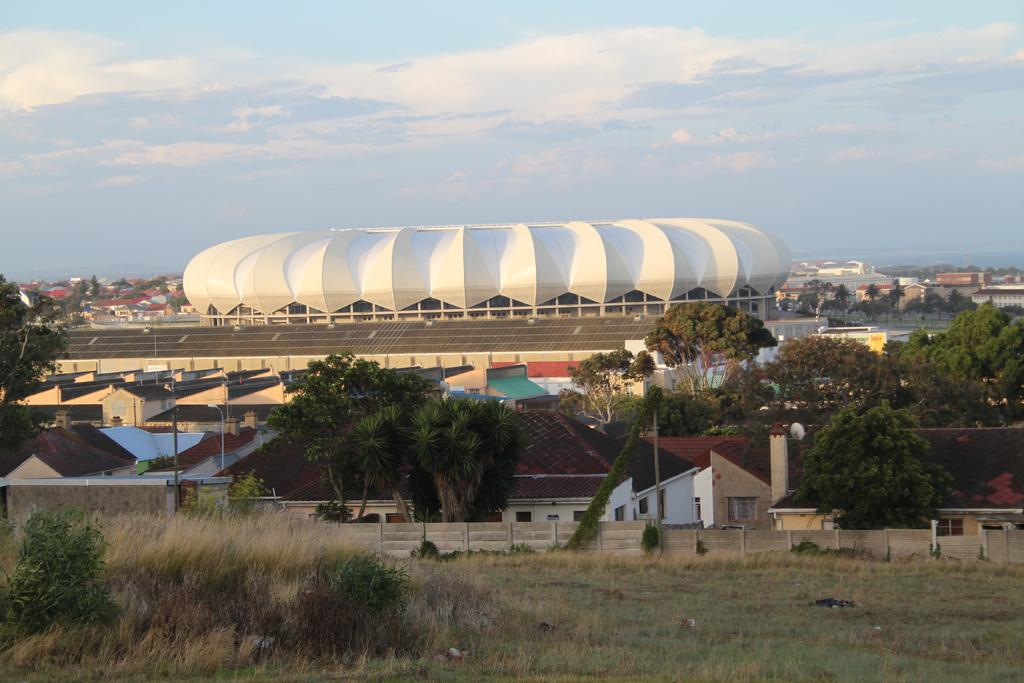What type of structures can be seen in the image? There are buildings in the image. What type of vegetation is present in the image? There are trees in the image. What type of ground surface is visible in the image? There is grass visible in the image. What type of vertical structures are present in the image? There are poles in the image. What part of the natural environment is visible in the image? The sky is visible in the background of the image. What type of prison can be seen in the image? There is no prison present in the image. Can you tell me how many letters are visible in the image? There is no reference to any letters in the image. 